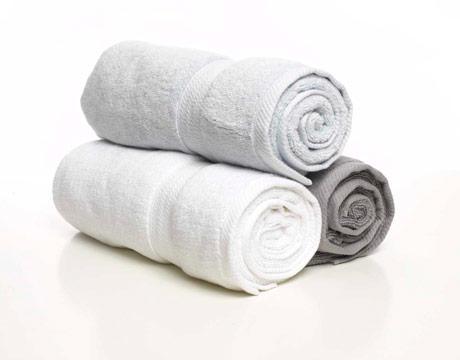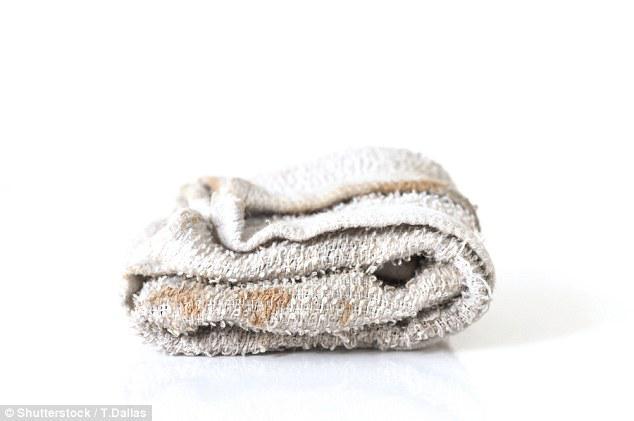The first image is the image on the left, the second image is the image on the right. For the images shown, is this caption "Exactly two large white folded towels are shown in one image." true? Answer yes or no. No. The first image is the image on the left, the second image is the image on the right. Given the left and right images, does the statement "There are at most 6 towels shown." hold true? Answer yes or no. Yes. 